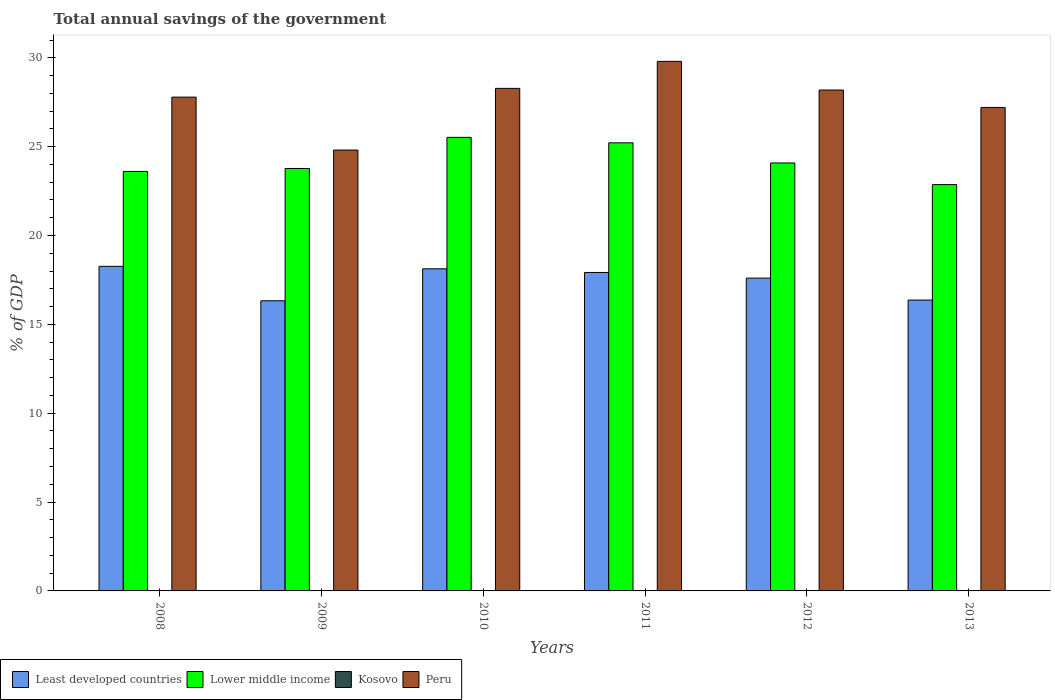How many different coloured bars are there?
Offer a terse response. 3. Are the number of bars per tick equal to the number of legend labels?
Offer a terse response. No. What is the total annual savings of the government in Least developed countries in 2011?
Your answer should be compact. 17.92. Across all years, what is the maximum total annual savings of the government in Least developed countries?
Your answer should be very brief. 18.27. Across all years, what is the minimum total annual savings of the government in Kosovo?
Ensure brevity in your answer.  0. In which year was the total annual savings of the government in Peru maximum?
Your response must be concise. 2011. What is the total total annual savings of the government in Kosovo in the graph?
Provide a short and direct response. 0. What is the difference between the total annual savings of the government in Peru in 2011 and that in 2012?
Make the answer very short. 1.61. What is the difference between the total annual savings of the government in Least developed countries in 2008 and the total annual savings of the government in Peru in 2009?
Offer a terse response. -6.54. In the year 2009, what is the difference between the total annual savings of the government in Least developed countries and total annual savings of the government in Lower middle income?
Keep it short and to the point. -7.45. What is the ratio of the total annual savings of the government in Lower middle income in 2009 to that in 2010?
Provide a short and direct response. 0.93. Is the total annual savings of the government in Lower middle income in 2008 less than that in 2010?
Ensure brevity in your answer.  Yes. Is the difference between the total annual savings of the government in Least developed countries in 2009 and 2013 greater than the difference between the total annual savings of the government in Lower middle income in 2009 and 2013?
Ensure brevity in your answer.  No. What is the difference between the highest and the second highest total annual savings of the government in Least developed countries?
Keep it short and to the point. 0.14. What is the difference between the highest and the lowest total annual savings of the government in Peru?
Provide a short and direct response. 4.99. Is the sum of the total annual savings of the government in Lower middle income in 2011 and 2012 greater than the maximum total annual savings of the government in Peru across all years?
Your answer should be compact. Yes. Is it the case that in every year, the sum of the total annual savings of the government in Lower middle income and total annual savings of the government in Peru is greater than the sum of total annual savings of the government in Kosovo and total annual savings of the government in Least developed countries?
Offer a very short reply. Yes. How many bars are there?
Provide a short and direct response. 18. Are all the bars in the graph horizontal?
Offer a very short reply. No. How many years are there in the graph?
Offer a terse response. 6. Does the graph contain grids?
Give a very brief answer. No. How many legend labels are there?
Your answer should be compact. 4. What is the title of the graph?
Provide a succinct answer. Total annual savings of the government. Does "Guinea-Bissau" appear as one of the legend labels in the graph?
Provide a short and direct response. No. What is the label or title of the Y-axis?
Keep it short and to the point. % of GDP. What is the % of GDP in Least developed countries in 2008?
Keep it short and to the point. 18.27. What is the % of GDP in Lower middle income in 2008?
Offer a terse response. 23.61. What is the % of GDP of Kosovo in 2008?
Your response must be concise. 0. What is the % of GDP in Peru in 2008?
Ensure brevity in your answer.  27.79. What is the % of GDP in Least developed countries in 2009?
Your answer should be compact. 16.33. What is the % of GDP of Lower middle income in 2009?
Offer a terse response. 23.77. What is the % of GDP in Peru in 2009?
Your response must be concise. 24.81. What is the % of GDP of Least developed countries in 2010?
Your response must be concise. 18.13. What is the % of GDP of Lower middle income in 2010?
Provide a short and direct response. 25.53. What is the % of GDP of Peru in 2010?
Your answer should be very brief. 28.28. What is the % of GDP of Least developed countries in 2011?
Make the answer very short. 17.92. What is the % of GDP of Lower middle income in 2011?
Offer a very short reply. 25.22. What is the % of GDP of Peru in 2011?
Make the answer very short. 29.8. What is the % of GDP of Least developed countries in 2012?
Keep it short and to the point. 17.6. What is the % of GDP of Lower middle income in 2012?
Your answer should be very brief. 24.08. What is the % of GDP of Kosovo in 2012?
Offer a very short reply. 0. What is the % of GDP in Peru in 2012?
Provide a succinct answer. 28.19. What is the % of GDP in Least developed countries in 2013?
Give a very brief answer. 16.37. What is the % of GDP of Lower middle income in 2013?
Provide a succinct answer. 22.87. What is the % of GDP of Peru in 2013?
Give a very brief answer. 27.21. Across all years, what is the maximum % of GDP of Least developed countries?
Offer a terse response. 18.27. Across all years, what is the maximum % of GDP in Lower middle income?
Your answer should be compact. 25.53. Across all years, what is the maximum % of GDP of Peru?
Your answer should be very brief. 29.8. Across all years, what is the minimum % of GDP of Least developed countries?
Give a very brief answer. 16.33. Across all years, what is the minimum % of GDP of Lower middle income?
Make the answer very short. 22.87. Across all years, what is the minimum % of GDP in Peru?
Make the answer very short. 24.81. What is the total % of GDP of Least developed countries in the graph?
Offer a terse response. 104.61. What is the total % of GDP in Lower middle income in the graph?
Give a very brief answer. 145.07. What is the total % of GDP of Kosovo in the graph?
Your answer should be very brief. 0. What is the total % of GDP in Peru in the graph?
Your answer should be very brief. 166.08. What is the difference between the % of GDP in Least developed countries in 2008 and that in 2009?
Offer a very short reply. 1.94. What is the difference between the % of GDP in Lower middle income in 2008 and that in 2009?
Provide a short and direct response. -0.17. What is the difference between the % of GDP in Peru in 2008 and that in 2009?
Provide a short and direct response. 2.98. What is the difference between the % of GDP of Least developed countries in 2008 and that in 2010?
Provide a succinct answer. 0.14. What is the difference between the % of GDP of Lower middle income in 2008 and that in 2010?
Give a very brief answer. -1.92. What is the difference between the % of GDP of Peru in 2008 and that in 2010?
Ensure brevity in your answer.  -0.49. What is the difference between the % of GDP of Least developed countries in 2008 and that in 2011?
Your answer should be compact. 0.35. What is the difference between the % of GDP of Lower middle income in 2008 and that in 2011?
Provide a succinct answer. -1.61. What is the difference between the % of GDP of Peru in 2008 and that in 2011?
Offer a very short reply. -2.01. What is the difference between the % of GDP of Least developed countries in 2008 and that in 2012?
Offer a terse response. 0.66. What is the difference between the % of GDP of Lower middle income in 2008 and that in 2012?
Ensure brevity in your answer.  -0.48. What is the difference between the % of GDP of Peru in 2008 and that in 2012?
Offer a very short reply. -0.4. What is the difference between the % of GDP in Least developed countries in 2008 and that in 2013?
Offer a terse response. 1.9. What is the difference between the % of GDP of Lower middle income in 2008 and that in 2013?
Your answer should be very brief. 0.74. What is the difference between the % of GDP of Peru in 2008 and that in 2013?
Keep it short and to the point. 0.58. What is the difference between the % of GDP of Least developed countries in 2009 and that in 2010?
Provide a short and direct response. -1.8. What is the difference between the % of GDP of Lower middle income in 2009 and that in 2010?
Provide a short and direct response. -1.75. What is the difference between the % of GDP of Peru in 2009 and that in 2010?
Your answer should be compact. -3.47. What is the difference between the % of GDP of Least developed countries in 2009 and that in 2011?
Your answer should be very brief. -1.59. What is the difference between the % of GDP of Lower middle income in 2009 and that in 2011?
Give a very brief answer. -1.45. What is the difference between the % of GDP of Peru in 2009 and that in 2011?
Ensure brevity in your answer.  -4.99. What is the difference between the % of GDP in Least developed countries in 2009 and that in 2012?
Make the answer very short. -1.28. What is the difference between the % of GDP in Lower middle income in 2009 and that in 2012?
Offer a terse response. -0.31. What is the difference between the % of GDP of Peru in 2009 and that in 2012?
Your answer should be very brief. -3.38. What is the difference between the % of GDP of Least developed countries in 2009 and that in 2013?
Ensure brevity in your answer.  -0.04. What is the difference between the % of GDP of Lower middle income in 2009 and that in 2013?
Offer a very short reply. 0.91. What is the difference between the % of GDP of Peru in 2009 and that in 2013?
Provide a short and direct response. -2.4. What is the difference between the % of GDP in Least developed countries in 2010 and that in 2011?
Offer a terse response. 0.21. What is the difference between the % of GDP of Lower middle income in 2010 and that in 2011?
Provide a succinct answer. 0.31. What is the difference between the % of GDP of Peru in 2010 and that in 2011?
Ensure brevity in your answer.  -1.52. What is the difference between the % of GDP in Least developed countries in 2010 and that in 2012?
Offer a terse response. 0.52. What is the difference between the % of GDP of Lower middle income in 2010 and that in 2012?
Provide a short and direct response. 1.44. What is the difference between the % of GDP of Peru in 2010 and that in 2012?
Keep it short and to the point. 0.09. What is the difference between the % of GDP in Least developed countries in 2010 and that in 2013?
Your answer should be compact. 1.76. What is the difference between the % of GDP in Lower middle income in 2010 and that in 2013?
Provide a succinct answer. 2.66. What is the difference between the % of GDP in Peru in 2010 and that in 2013?
Your answer should be compact. 1.07. What is the difference between the % of GDP of Least developed countries in 2011 and that in 2012?
Give a very brief answer. 0.32. What is the difference between the % of GDP of Lower middle income in 2011 and that in 2012?
Your answer should be very brief. 1.13. What is the difference between the % of GDP of Peru in 2011 and that in 2012?
Give a very brief answer. 1.61. What is the difference between the % of GDP of Least developed countries in 2011 and that in 2013?
Your answer should be compact. 1.55. What is the difference between the % of GDP in Lower middle income in 2011 and that in 2013?
Offer a terse response. 2.35. What is the difference between the % of GDP of Peru in 2011 and that in 2013?
Make the answer very short. 2.59. What is the difference between the % of GDP in Least developed countries in 2012 and that in 2013?
Provide a succinct answer. 1.24. What is the difference between the % of GDP in Lower middle income in 2012 and that in 2013?
Your answer should be very brief. 1.22. What is the difference between the % of GDP of Peru in 2012 and that in 2013?
Offer a terse response. 0.98. What is the difference between the % of GDP of Least developed countries in 2008 and the % of GDP of Lower middle income in 2009?
Your response must be concise. -5.51. What is the difference between the % of GDP in Least developed countries in 2008 and the % of GDP in Peru in 2009?
Keep it short and to the point. -6.54. What is the difference between the % of GDP in Lower middle income in 2008 and the % of GDP in Peru in 2009?
Give a very brief answer. -1.2. What is the difference between the % of GDP of Least developed countries in 2008 and the % of GDP of Lower middle income in 2010?
Your response must be concise. -7.26. What is the difference between the % of GDP of Least developed countries in 2008 and the % of GDP of Peru in 2010?
Make the answer very short. -10.02. What is the difference between the % of GDP of Lower middle income in 2008 and the % of GDP of Peru in 2010?
Ensure brevity in your answer.  -4.68. What is the difference between the % of GDP in Least developed countries in 2008 and the % of GDP in Lower middle income in 2011?
Provide a short and direct response. -6.95. What is the difference between the % of GDP in Least developed countries in 2008 and the % of GDP in Peru in 2011?
Ensure brevity in your answer.  -11.54. What is the difference between the % of GDP in Lower middle income in 2008 and the % of GDP in Peru in 2011?
Your answer should be very brief. -6.2. What is the difference between the % of GDP in Least developed countries in 2008 and the % of GDP in Lower middle income in 2012?
Your answer should be very brief. -5.82. What is the difference between the % of GDP of Least developed countries in 2008 and the % of GDP of Peru in 2012?
Give a very brief answer. -9.92. What is the difference between the % of GDP of Lower middle income in 2008 and the % of GDP of Peru in 2012?
Provide a short and direct response. -4.58. What is the difference between the % of GDP in Least developed countries in 2008 and the % of GDP in Lower middle income in 2013?
Your response must be concise. -4.6. What is the difference between the % of GDP of Least developed countries in 2008 and the % of GDP of Peru in 2013?
Your response must be concise. -8.94. What is the difference between the % of GDP of Lower middle income in 2008 and the % of GDP of Peru in 2013?
Give a very brief answer. -3.6. What is the difference between the % of GDP in Least developed countries in 2009 and the % of GDP in Lower middle income in 2010?
Ensure brevity in your answer.  -9.2. What is the difference between the % of GDP of Least developed countries in 2009 and the % of GDP of Peru in 2010?
Offer a very short reply. -11.95. What is the difference between the % of GDP in Lower middle income in 2009 and the % of GDP in Peru in 2010?
Offer a very short reply. -4.51. What is the difference between the % of GDP of Least developed countries in 2009 and the % of GDP of Lower middle income in 2011?
Keep it short and to the point. -8.89. What is the difference between the % of GDP of Least developed countries in 2009 and the % of GDP of Peru in 2011?
Keep it short and to the point. -13.47. What is the difference between the % of GDP of Lower middle income in 2009 and the % of GDP of Peru in 2011?
Provide a succinct answer. -6.03. What is the difference between the % of GDP of Least developed countries in 2009 and the % of GDP of Lower middle income in 2012?
Your answer should be compact. -7.76. What is the difference between the % of GDP of Least developed countries in 2009 and the % of GDP of Peru in 2012?
Your response must be concise. -11.86. What is the difference between the % of GDP of Lower middle income in 2009 and the % of GDP of Peru in 2012?
Give a very brief answer. -4.41. What is the difference between the % of GDP of Least developed countries in 2009 and the % of GDP of Lower middle income in 2013?
Make the answer very short. -6.54. What is the difference between the % of GDP in Least developed countries in 2009 and the % of GDP in Peru in 2013?
Your answer should be compact. -10.88. What is the difference between the % of GDP in Lower middle income in 2009 and the % of GDP in Peru in 2013?
Keep it short and to the point. -3.44. What is the difference between the % of GDP in Least developed countries in 2010 and the % of GDP in Lower middle income in 2011?
Make the answer very short. -7.09. What is the difference between the % of GDP in Least developed countries in 2010 and the % of GDP in Peru in 2011?
Make the answer very short. -11.67. What is the difference between the % of GDP of Lower middle income in 2010 and the % of GDP of Peru in 2011?
Your response must be concise. -4.28. What is the difference between the % of GDP in Least developed countries in 2010 and the % of GDP in Lower middle income in 2012?
Your response must be concise. -5.96. What is the difference between the % of GDP of Least developed countries in 2010 and the % of GDP of Peru in 2012?
Your response must be concise. -10.06. What is the difference between the % of GDP in Lower middle income in 2010 and the % of GDP in Peru in 2012?
Provide a succinct answer. -2.66. What is the difference between the % of GDP in Least developed countries in 2010 and the % of GDP in Lower middle income in 2013?
Your answer should be very brief. -4.74. What is the difference between the % of GDP in Least developed countries in 2010 and the % of GDP in Peru in 2013?
Keep it short and to the point. -9.08. What is the difference between the % of GDP of Lower middle income in 2010 and the % of GDP of Peru in 2013?
Give a very brief answer. -1.68. What is the difference between the % of GDP of Least developed countries in 2011 and the % of GDP of Lower middle income in 2012?
Your response must be concise. -6.16. What is the difference between the % of GDP in Least developed countries in 2011 and the % of GDP in Peru in 2012?
Your answer should be very brief. -10.27. What is the difference between the % of GDP in Lower middle income in 2011 and the % of GDP in Peru in 2012?
Keep it short and to the point. -2.97. What is the difference between the % of GDP of Least developed countries in 2011 and the % of GDP of Lower middle income in 2013?
Offer a terse response. -4.95. What is the difference between the % of GDP in Least developed countries in 2011 and the % of GDP in Peru in 2013?
Keep it short and to the point. -9.29. What is the difference between the % of GDP in Lower middle income in 2011 and the % of GDP in Peru in 2013?
Your answer should be compact. -1.99. What is the difference between the % of GDP in Least developed countries in 2012 and the % of GDP in Lower middle income in 2013?
Provide a short and direct response. -5.26. What is the difference between the % of GDP of Least developed countries in 2012 and the % of GDP of Peru in 2013?
Your response must be concise. -9.61. What is the difference between the % of GDP in Lower middle income in 2012 and the % of GDP in Peru in 2013?
Provide a short and direct response. -3.12. What is the average % of GDP in Least developed countries per year?
Ensure brevity in your answer.  17.44. What is the average % of GDP of Lower middle income per year?
Offer a very short reply. 24.18. What is the average % of GDP of Peru per year?
Keep it short and to the point. 27.68. In the year 2008, what is the difference between the % of GDP in Least developed countries and % of GDP in Lower middle income?
Your response must be concise. -5.34. In the year 2008, what is the difference between the % of GDP in Least developed countries and % of GDP in Peru?
Offer a very short reply. -9.52. In the year 2008, what is the difference between the % of GDP of Lower middle income and % of GDP of Peru?
Give a very brief answer. -4.18. In the year 2009, what is the difference between the % of GDP in Least developed countries and % of GDP in Lower middle income?
Provide a short and direct response. -7.45. In the year 2009, what is the difference between the % of GDP of Least developed countries and % of GDP of Peru?
Make the answer very short. -8.48. In the year 2009, what is the difference between the % of GDP in Lower middle income and % of GDP in Peru?
Provide a short and direct response. -1.04. In the year 2010, what is the difference between the % of GDP of Least developed countries and % of GDP of Lower middle income?
Your response must be concise. -7.4. In the year 2010, what is the difference between the % of GDP of Least developed countries and % of GDP of Peru?
Offer a terse response. -10.15. In the year 2010, what is the difference between the % of GDP of Lower middle income and % of GDP of Peru?
Provide a succinct answer. -2.76. In the year 2011, what is the difference between the % of GDP in Least developed countries and % of GDP in Lower middle income?
Ensure brevity in your answer.  -7.3. In the year 2011, what is the difference between the % of GDP in Least developed countries and % of GDP in Peru?
Your response must be concise. -11.88. In the year 2011, what is the difference between the % of GDP of Lower middle income and % of GDP of Peru?
Offer a terse response. -4.58. In the year 2012, what is the difference between the % of GDP in Least developed countries and % of GDP in Lower middle income?
Make the answer very short. -6.48. In the year 2012, what is the difference between the % of GDP in Least developed countries and % of GDP in Peru?
Offer a terse response. -10.58. In the year 2012, what is the difference between the % of GDP in Lower middle income and % of GDP in Peru?
Your response must be concise. -4.1. In the year 2013, what is the difference between the % of GDP in Least developed countries and % of GDP in Lower middle income?
Your answer should be very brief. -6.5. In the year 2013, what is the difference between the % of GDP of Least developed countries and % of GDP of Peru?
Offer a very short reply. -10.84. In the year 2013, what is the difference between the % of GDP in Lower middle income and % of GDP in Peru?
Ensure brevity in your answer.  -4.34. What is the ratio of the % of GDP in Least developed countries in 2008 to that in 2009?
Provide a succinct answer. 1.12. What is the ratio of the % of GDP in Peru in 2008 to that in 2009?
Provide a succinct answer. 1.12. What is the ratio of the % of GDP of Least developed countries in 2008 to that in 2010?
Provide a succinct answer. 1.01. What is the ratio of the % of GDP in Lower middle income in 2008 to that in 2010?
Provide a short and direct response. 0.92. What is the ratio of the % of GDP of Peru in 2008 to that in 2010?
Make the answer very short. 0.98. What is the ratio of the % of GDP of Least developed countries in 2008 to that in 2011?
Give a very brief answer. 1.02. What is the ratio of the % of GDP in Lower middle income in 2008 to that in 2011?
Offer a terse response. 0.94. What is the ratio of the % of GDP in Peru in 2008 to that in 2011?
Make the answer very short. 0.93. What is the ratio of the % of GDP in Least developed countries in 2008 to that in 2012?
Keep it short and to the point. 1.04. What is the ratio of the % of GDP of Lower middle income in 2008 to that in 2012?
Give a very brief answer. 0.98. What is the ratio of the % of GDP of Peru in 2008 to that in 2012?
Make the answer very short. 0.99. What is the ratio of the % of GDP of Least developed countries in 2008 to that in 2013?
Make the answer very short. 1.12. What is the ratio of the % of GDP in Lower middle income in 2008 to that in 2013?
Keep it short and to the point. 1.03. What is the ratio of the % of GDP of Peru in 2008 to that in 2013?
Your answer should be very brief. 1.02. What is the ratio of the % of GDP in Least developed countries in 2009 to that in 2010?
Your response must be concise. 0.9. What is the ratio of the % of GDP of Lower middle income in 2009 to that in 2010?
Offer a very short reply. 0.93. What is the ratio of the % of GDP in Peru in 2009 to that in 2010?
Ensure brevity in your answer.  0.88. What is the ratio of the % of GDP in Least developed countries in 2009 to that in 2011?
Offer a terse response. 0.91. What is the ratio of the % of GDP in Lower middle income in 2009 to that in 2011?
Your response must be concise. 0.94. What is the ratio of the % of GDP in Peru in 2009 to that in 2011?
Your response must be concise. 0.83. What is the ratio of the % of GDP of Least developed countries in 2009 to that in 2012?
Your answer should be compact. 0.93. What is the ratio of the % of GDP in Lower middle income in 2009 to that in 2012?
Provide a succinct answer. 0.99. What is the ratio of the % of GDP of Peru in 2009 to that in 2012?
Make the answer very short. 0.88. What is the ratio of the % of GDP in Lower middle income in 2009 to that in 2013?
Your answer should be very brief. 1.04. What is the ratio of the % of GDP in Peru in 2009 to that in 2013?
Ensure brevity in your answer.  0.91. What is the ratio of the % of GDP in Least developed countries in 2010 to that in 2011?
Your answer should be very brief. 1.01. What is the ratio of the % of GDP in Lower middle income in 2010 to that in 2011?
Keep it short and to the point. 1.01. What is the ratio of the % of GDP of Peru in 2010 to that in 2011?
Provide a short and direct response. 0.95. What is the ratio of the % of GDP of Least developed countries in 2010 to that in 2012?
Offer a very short reply. 1.03. What is the ratio of the % of GDP of Lower middle income in 2010 to that in 2012?
Offer a very short reply. 1.06. What is the ratio of the % of GDP in Peru in 2010 to that in 2012?
Provide a succinct answer. 1. What is the ratio of the % of GDP of Least developed countries in 2010 to that in 2013?
Your answer should be very brief. 1.11. What is the ratio of the % of GDP of Lower middle income in 2010 to that in 2013?
Your answer should be compact. 1.12. What is the ratio of the % of GDP of Peru in 2010 to that in 2013?
Provide a short and direct response. 1.04. What is the ratio of the % of GDP of Least developed countries in 2011 to that in 2012?
Offer a terse response. 1.02. What is the ratio of the % of GDP in Lower middle income in 2011 to that in 2012?
Provide a short and direct response. 1.05. What is the ratio of the % of GDP of Peru in 2011 to that in 2012?
Offer a terse response. 1.06. What is the ratio of the % of GDP of Least developed countries in 2011 to that in 2013?
Ensure brevity in your answer.  1.09. What is the ratio of the % of GDP in Lower middle income in 2011 to that in 2013?
Give a very brief answer. 1.1. What is the ratio of the % of GDP in Peru in 2011 to that in 2013?
Make the answer very short. 1.1. What is the ratio of the % of GDP in Least developed countries in 2012 to that in 2013?
Keep it short and to the point. 1.08. What is the ratio of the % of GDP in Lower middle income in 2012 to that in 2013?
Keep it short and to the point. 1.05. What is the ratio of the % of GDP in Peru in 2012 to that in 2013?
Your answer should be very brief. 1.04. What is the difference between the highest and the second highest % of GDP in Least developed countries?
Offer a terse response. 0.14. What is the difference between the highest and the second highest % of GDP of Lower middle income?
Give a very brief answer. 0.31. What is the difference between the highest and the second highest % of GDP of Peru?
Provide a succinct answer. 1.52. What is the difference between the highest and the lowest % of GDP in Least developed countries?
Make the answer very short. 1.94. What is the difference between the highest and the lowest % of GDP of Lower middle income?
Your response must be concise. 2.66. What is the difference between the highest and the lowest % of GDP in Peru?
Your answer should be very brief. 4.99. 